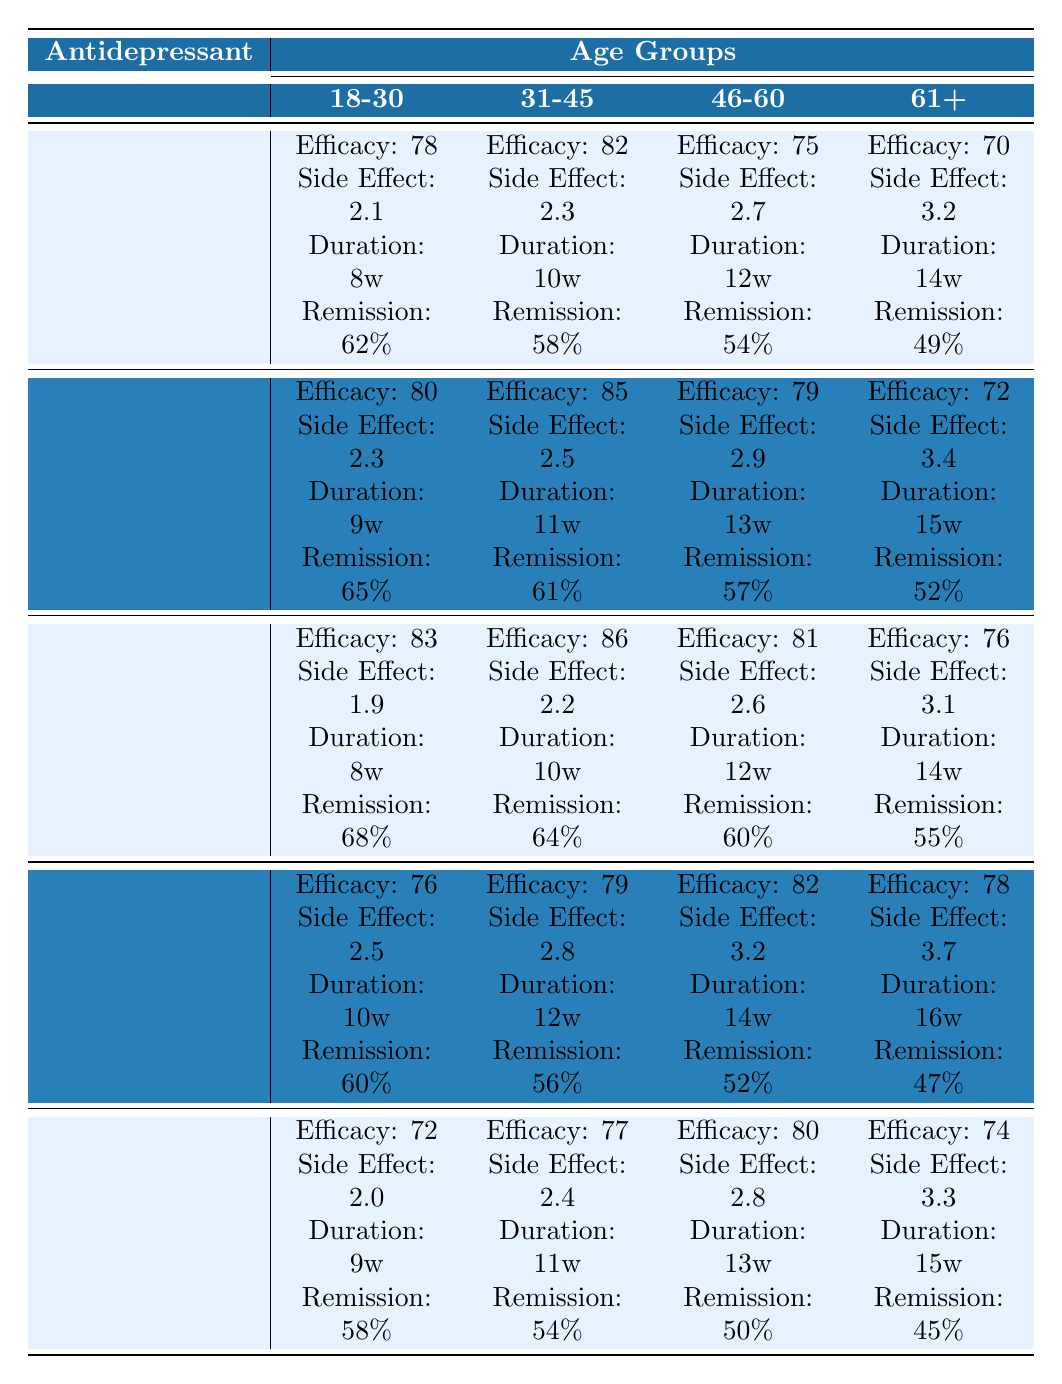What is the highest efficacy score among antidepressants for the age group 18-30? For the age group 18-30, the efficacy scores are 78 (Fluoxetine), 80 (Sertraline), 83 (Escitalopram), 76 (Venlafaxine), and 72 (Bupropion). The highest score is 83 from Escitalopram.
Answer: 83 Which antidepressant has the lowest side effect severity for the age group 46-60? Checking the side effect severity for the age group 46-60, the values are 2.7 (Fluoxetine), 2.9 (Sertraline), 2.6 (Escitalopram), 3.2 (Venlafaxine), and 2.8 (Bupropion). The lowest severity is 2.6 from Escitalopram.
Answer: Escitalopram What is the average remission rate for Bupropion across all age groups? The remission rates for Bupropion across age groups are 58% (18-30), 54% (31-45), 50% (46-60), and 45% (61+). The average is calculated as (58 + 54 + 50 + 45) / 4 = 52.25%.
Answer: 52.25% Is the average efficacy score for Sertraline higher than that for Fluoxetine? The efficacy scores for Sertraline (80, 85, 79, 72) average to (80 + 85 + 79 + 72) / 4 = 78.5, and for Fluoxetine (78, 82, 75, 70) it averages to (78 + 82 + 75 + 70) / 4 = 76.25. Since 78.5 > 76.25, the statement is true.
Answer: Yes Which age group experiences the longest treatment duration on average for Venlafaxine? The treatment durations for Venlafaxine across age groups are 10 weeks (18-30), 12 weeks (31-45), 14 weeks (46-60), and 16 weeks (61+). The average duration is (10 + 12 + 14 + 16) / 4 = 13 weeks, meaning that the longest duration occurs in the 61+ age group.
Answer: 16 weeks What is the difference in efficacy scores between Escitalopram and Bupropion for the age group 61+? The efficacy score for Escitalopram in the age group 61+ is 76, while for Bupropion it is 74. The difference is calculated as 76 - 74 = 2.
Answer: 2 Which antidepressant shows the highest average side effect severity across all age groups? The side effects for each antidepressant are as follows: Fluoxetine (2.1, 2.3, 2.7, 3.2), Sertraline (2.3, 2.5, 2.9, 3.4), Escitalopram (1.9, 2.2, 2.6, 3.1), Venlafaxine (2.5, 2.8, 3.2, 3.7), and Bupropion (2.0, 2.4, 2.8, 3.3). The averages are Fluoxetine: 2.575, Sertraline: 2.775, Escitalopram: 2.225, Venlafaxine: 2.775, Bupropion: 2.575. Sertraline and Venlafaxine show the highest average at 2.775.
Answer: Sertraline and Venlafaxine Is the efficacy score for Venlafaxine in the 31-45 age group lower than that for Fluoxetine in the same age group? The efficacy for Venlafaxine in the 31-45 age group is 79, and for Fluoxetine, it is 82. Since 79 is less than 82, the statement is true.
Answer: Yes What is the maximum remission rate percentage across all antidepressants for the age group 31-45? The remission rates for the age group 31-45 are: Fluoxetine 58%, Sertraline 61%, Escitalopram 64%, Venlafaxine 56%, and Bupropion 54%. The maximum is from Escitalopram at 64%.
Answer: 64% Which antidepressant has the lowest average efficacy score across all age groups? The total efficacy scores for each antidepressant: Fluoxetine (305), Sertraline (316), Escitalopram (326), Venlafaxine (315), and Bupropion (283). The averages are Fluoxetine: 76.25, Sertraline: 79, Escitalopram: 81.5, Venlafaxine: 78.75, Bupropion: 70.75. Bupropion has the lowest average efficacy score.
Answer: Bupropion 